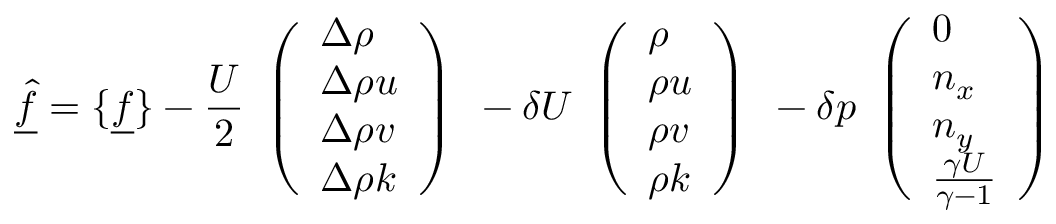Convert formula to latex. <formula><loc_0><loc_0><loc_500><loc_500>\underline { { \hat { f } } } = \{ \underline { f } \} - \frac { U } { 2 } \begin{array} { l } { \left ( \begin{array} { l } { \Delta \rho } \\ { \Delta \rho u } \\ { \Delta \rho v } \\ { \Delta \rho k } \end{array} \right ) } \end{array} - \delta U \begin{array} { l } { \left ( \begin{array} { l } { \rho } \\ { \rho u } \\ { \rho v } \\ { \rho k } \end{array} \right ) } \end{array} - \delta p \begin{array} { l } { \left ( \begin{array} { l } { 0 } \\ { n _ { x } } \\ { n _ { y } } \\ { \frac { \gamma U } { \gamma - 1 } } \end{array} \right ) } \end{array}</formula> 